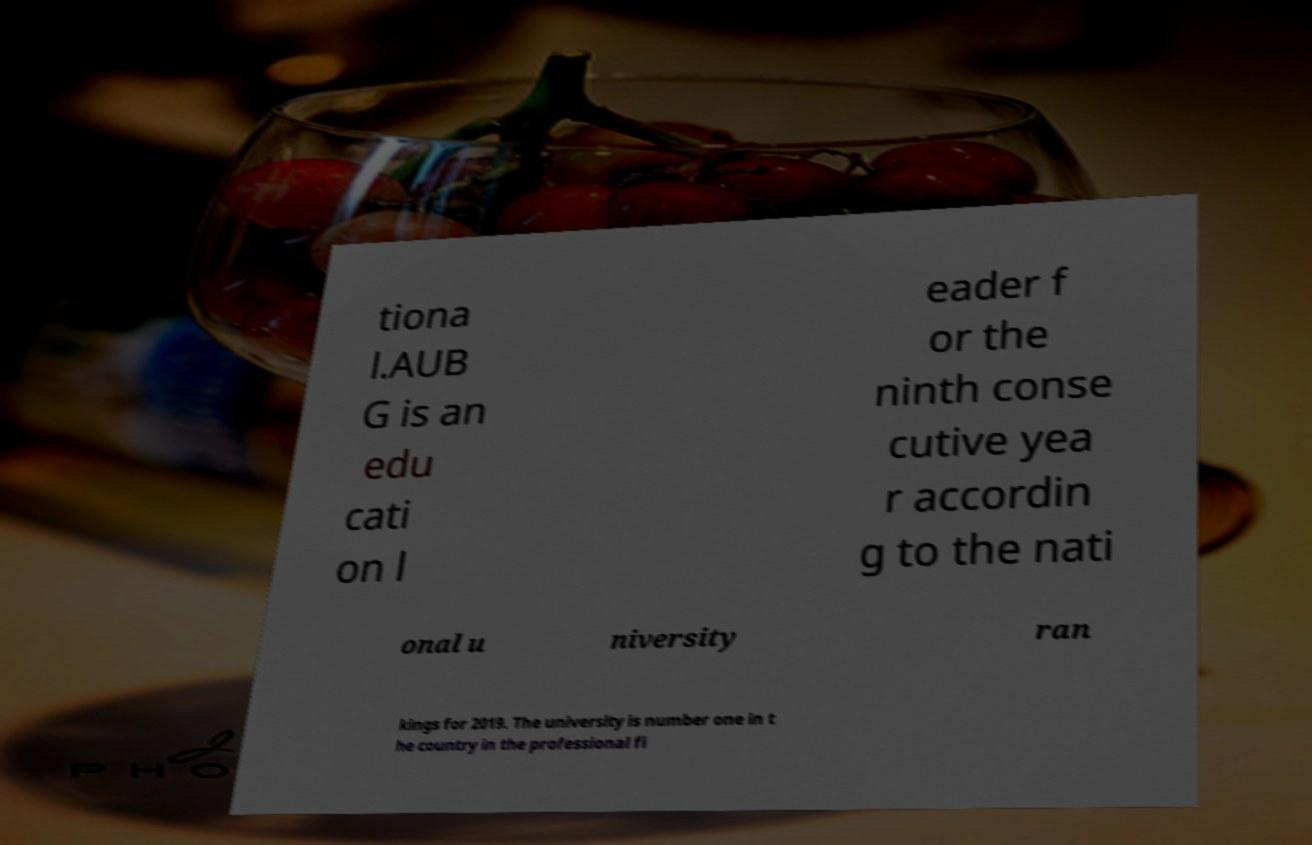There's text embedded in this image that I need extracted. Can you transcribe it verbatim? tiona l.AUB G is an edu cati on l eader f or the ninth conse cutive yea r accordin g to the nati onal u niversity ran kings for 2019. The university is number one in t he country in the professional fi 